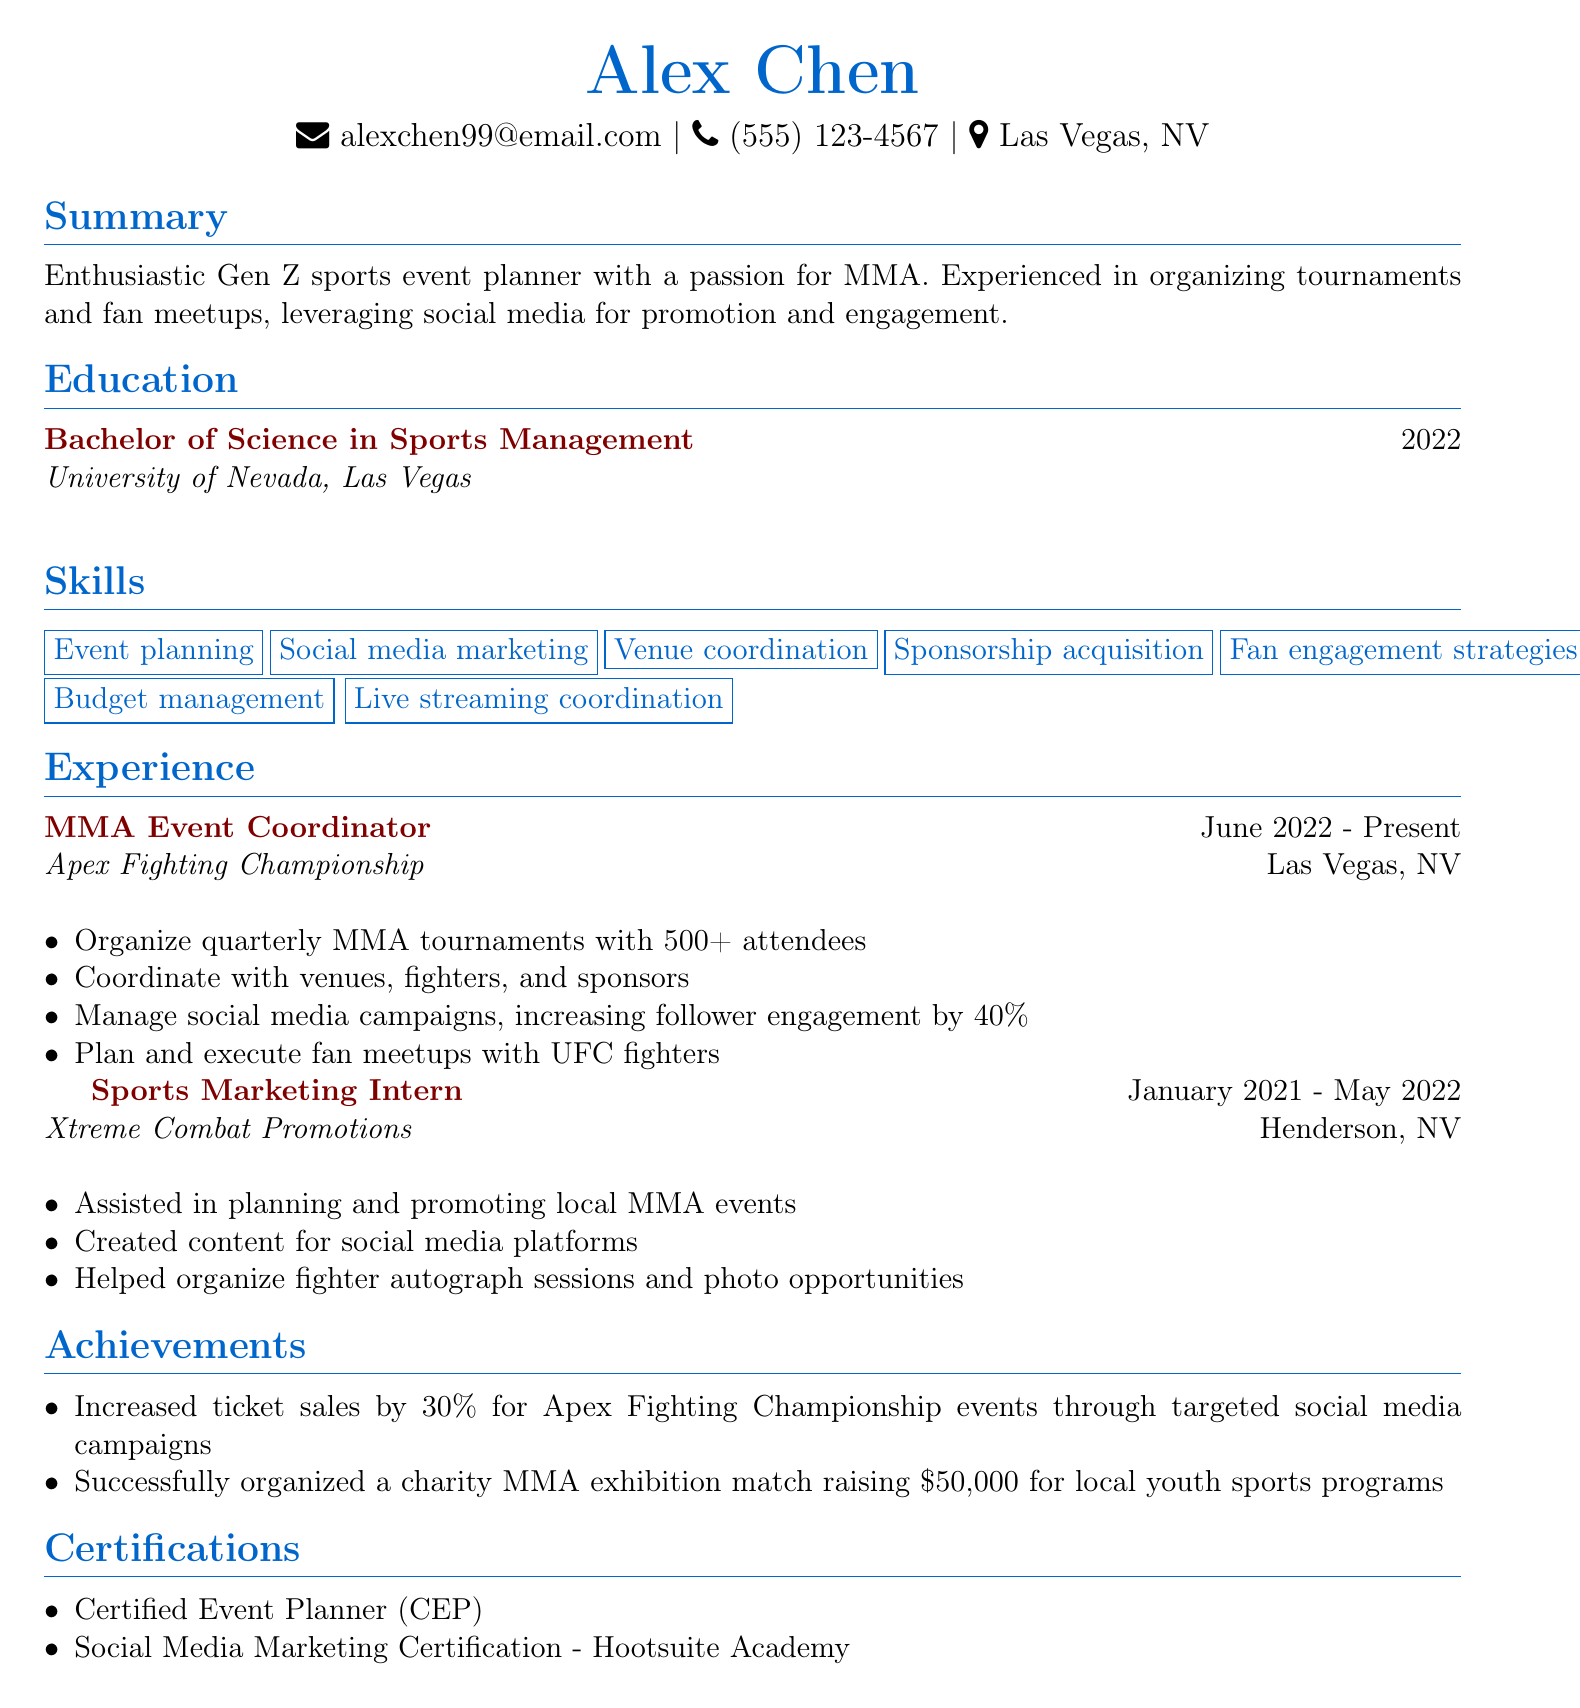What is the name of the applicant? The name of the applicant is mentioned at the top of the CV as Alex Chen.
Answer: Alex Chen What is the degree earned by the applicant? The document specifies that the applicant earned a Bachelor of Science in Sports Management.
Answer: Bachelor of Science in Sports Management Where is the current job location for the applicant? The applicant's current job location as mentioned in the document is Las Vegas, NV.
Answer: Las Vegas, NV What percentage did follower engagement increase by in social media campaigns? The document states that follower engagement increased by 40% through social media campaigns managed by the applicant.
Answer: 40% How much money was raised through the charity MMA exhibition match? According to the document, the charity MMA exhibition match raised $50,000 for local youth sports programs.
Answer: $50,000 What is one of the skills listed on the CV? The applicant lists several skills; one of them is event planning.
Answer: Event planning Which company has the applicant worked for since June 2022? The document identifies Apex Fighting Championship as the company where the applicant has been working since June 2022.
Answer: Apex Fighting Championship What certification does the applicant have that relates to event planning? The applicant holds a Certified Event Planner (CEP) certification according to the document.
Answer: Certified Event Planner (CEP) How long was the applicant a Sports Marketing Intern? The duration of the Sports Marketing Intern position was from January 2021 to May 2022, which is approximately 16 months.
Answer: 16 months 